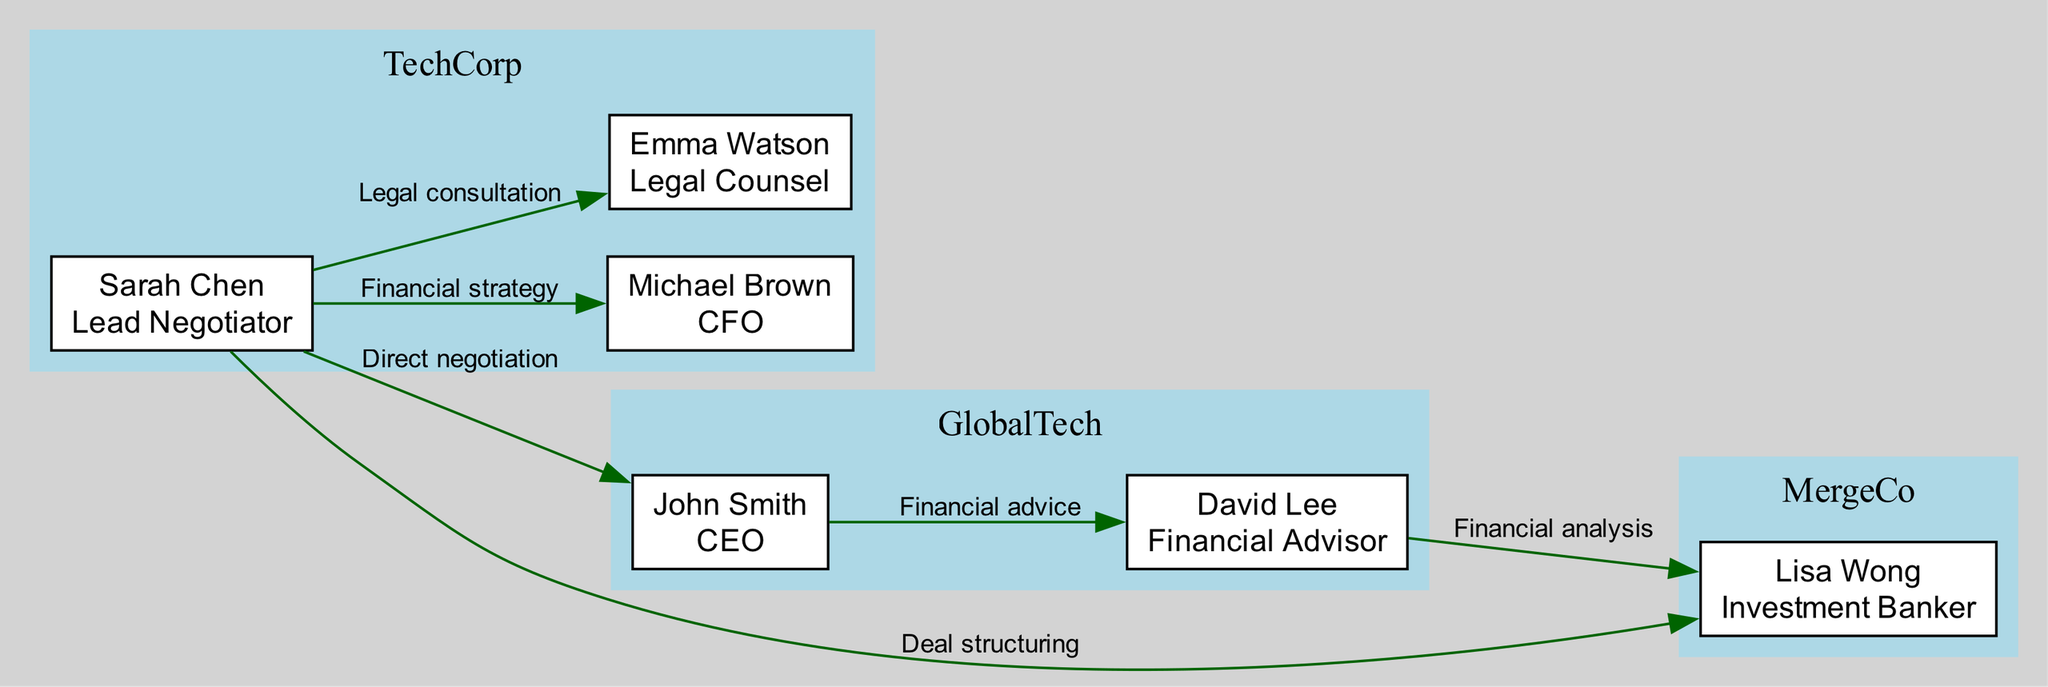What is the role of Michael Brown? Michael Brown is identified in the diagram as "CFO" under the company "TechCorp." This is found by locating his node in the diagram where each node contains the name and role of the individual.
Answer: CFO How many edges connect Sarah Chen to other nodes? By analyzing the edges originating from Sarah Chen's node, there are four edges indicating various relationships (financial strategy, legal consultation, direct negotiation, deal structuring) connecting her to other stakeholders.
Answer: 4 Who provides financial advice to John Smith? The edge originating from John Smith's node leads to David Lee, indicating that David Lee provides financial advice to John Smith, as shown by the label on the edge connecting these two nodes.
Answer: David Lee What relationship connects Sarah Chen and John Smith? Sarah Chen and John Smith are connected through a direct negotiation relationship. This is evidenced by the edge labeled "Direct negotiation" that directly links their two nodes in the diagram.
Answer: Direct negotiation Which two roles are connected by a financial analysis relationship? The financial analysis relationship is indicated by the edge from David Lee's node to Lisa Wong's node, showing that David Lee's role as Financial Advisor is connected to Lisa Wong's role as Investment Banker through that label on the edge.
Answer: Financial Advisor and Investment Banker 